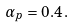Convert formula to latex. <formula><loc_0><loc_0><loc_500><loc_500>\alpha _ { p } = 0 . 4 \, .</formula> 